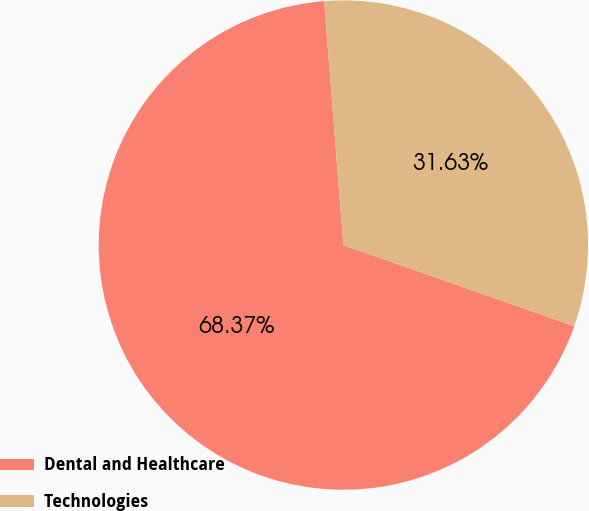<chart> <loc_0><loc_0><loc_500><loc_500><pie_chart><fcel>Dental and Healthcare<fcel>Technologies<nl><fcel>68.37%<fcel>31.63%<nl></chart> 